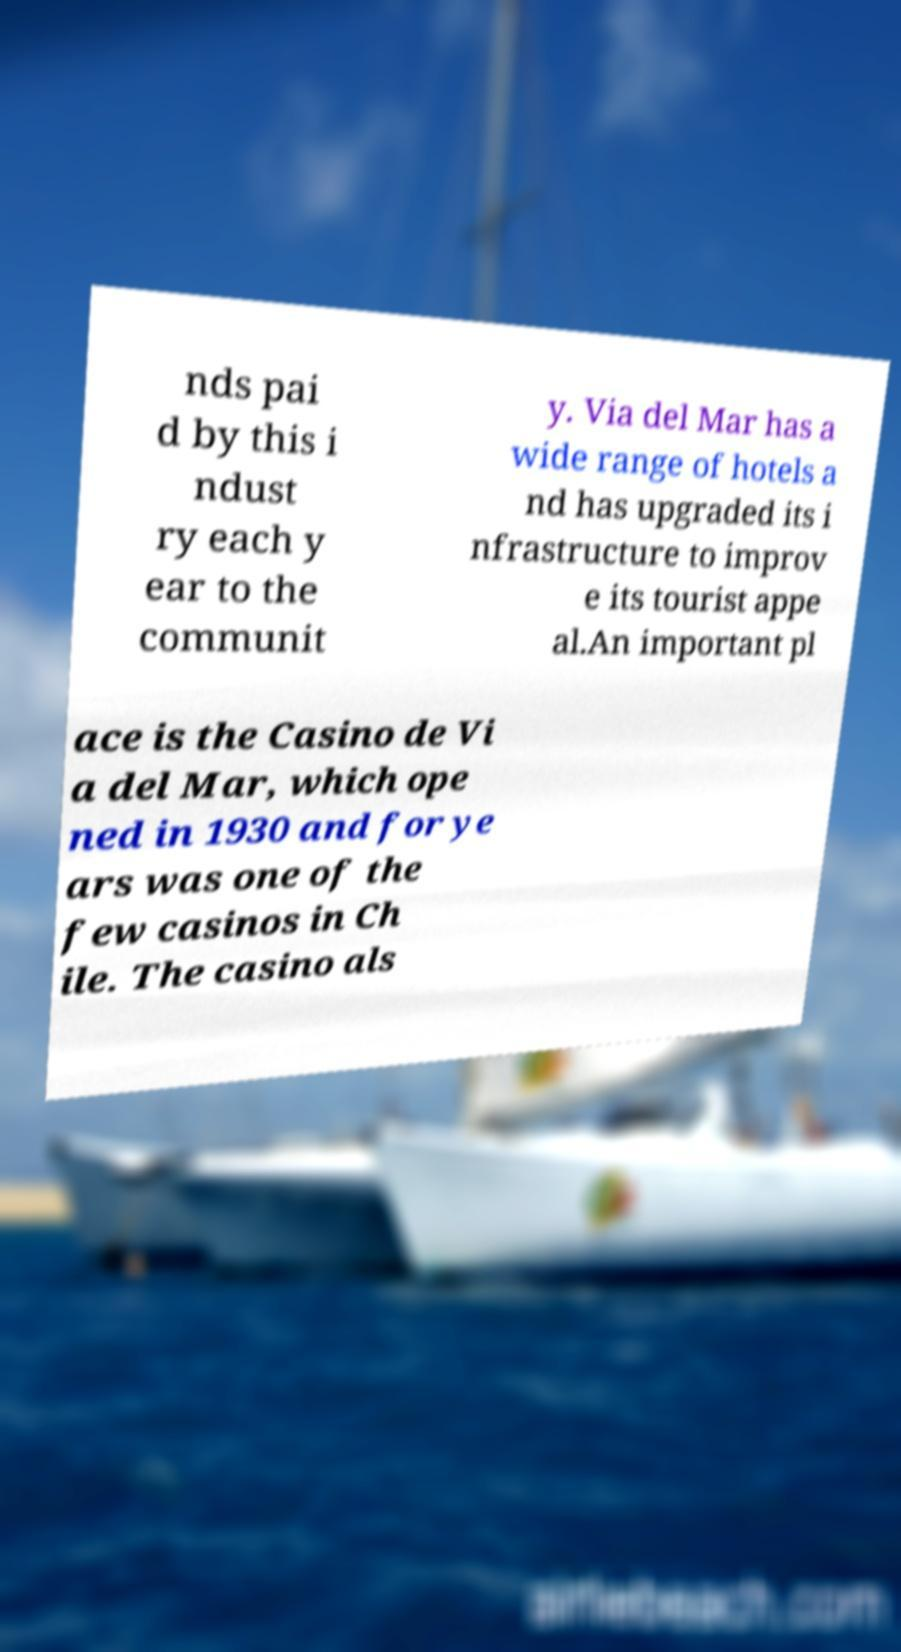Can you accurately transcribe the text from the provided image for me? nds pai d by this i ndust ry each y ear to the communit y. Via del Mar has a wide range of hotels a nd has upgraded its i nfrastructure to improv e its tourist appe al.An important pl ace is the Casino de Vi a del Mar, which ope ned in 1930 and for ye ars was one of the few casinos in Ch ile. The casino als 